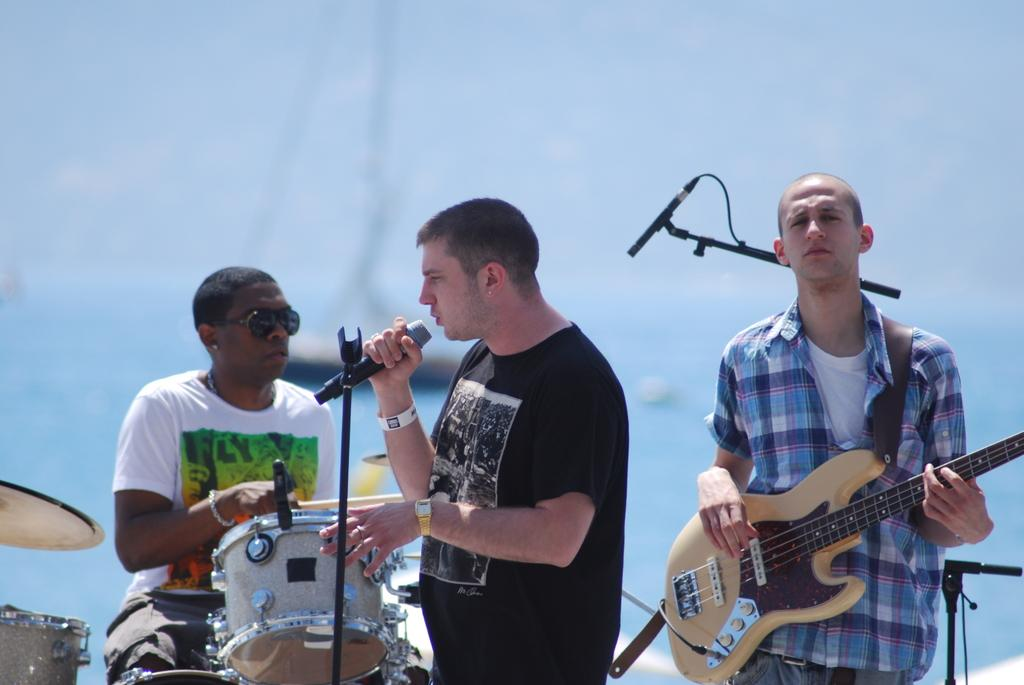How many people are in the image? There are three men in the image. What are the men doing in the image? One man is playing a guitar, another man is singing into a microphone, and the third man is sitting and playing drums. What type of hydrant can be seen in the background of the image? There is no hydrant visible in the image. What territory is being claimed by the men in the image? The image does not depict any territorial claims or disputes. 